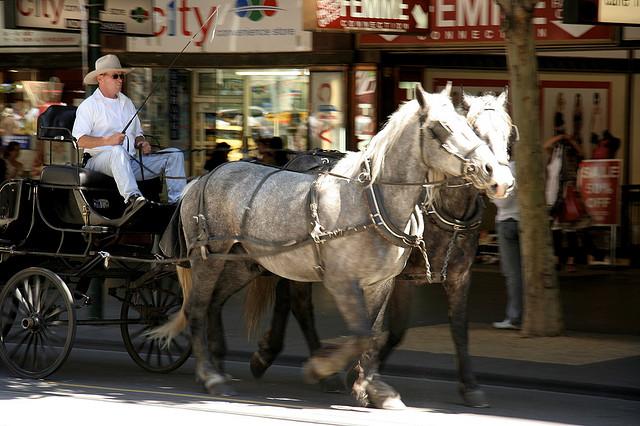What is the name of the street in the picture?
Short answer required. Main. What is the main color of the wagon?
Short answer required. Black. What is on the man's head?
Give a very brief answer. Hat. How many horses are pulling the cart?
Keep it brief. 2. What color is the driver's hat?
Answer briefly. Tan. Are these cart horses treated humanely?
Be succinct. Yes. 